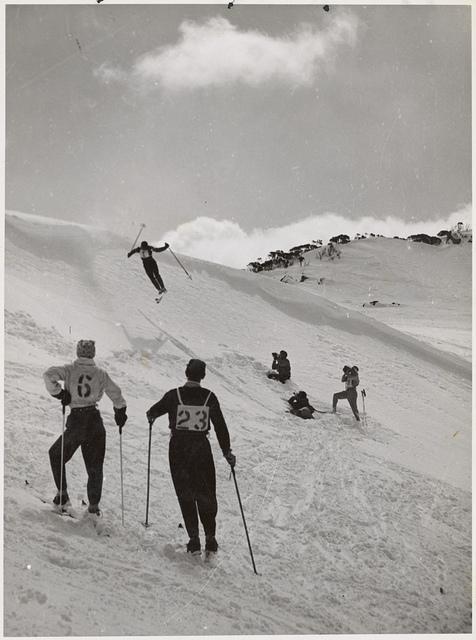Is there snow on the ground?
Write a very short answer. Yes. How many photographers are there?
Write a very short answer. 3. Is the wind blowing?
Keep it brief. No. 